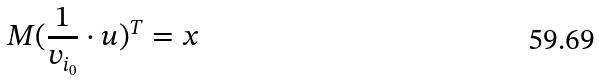<formula> <loc_0><loc_0><loc_500><loc_500>M ( \frac { 1 } { v _ { i _ { 0 } } } \cdot u ) ^ { T } = x</formula> 